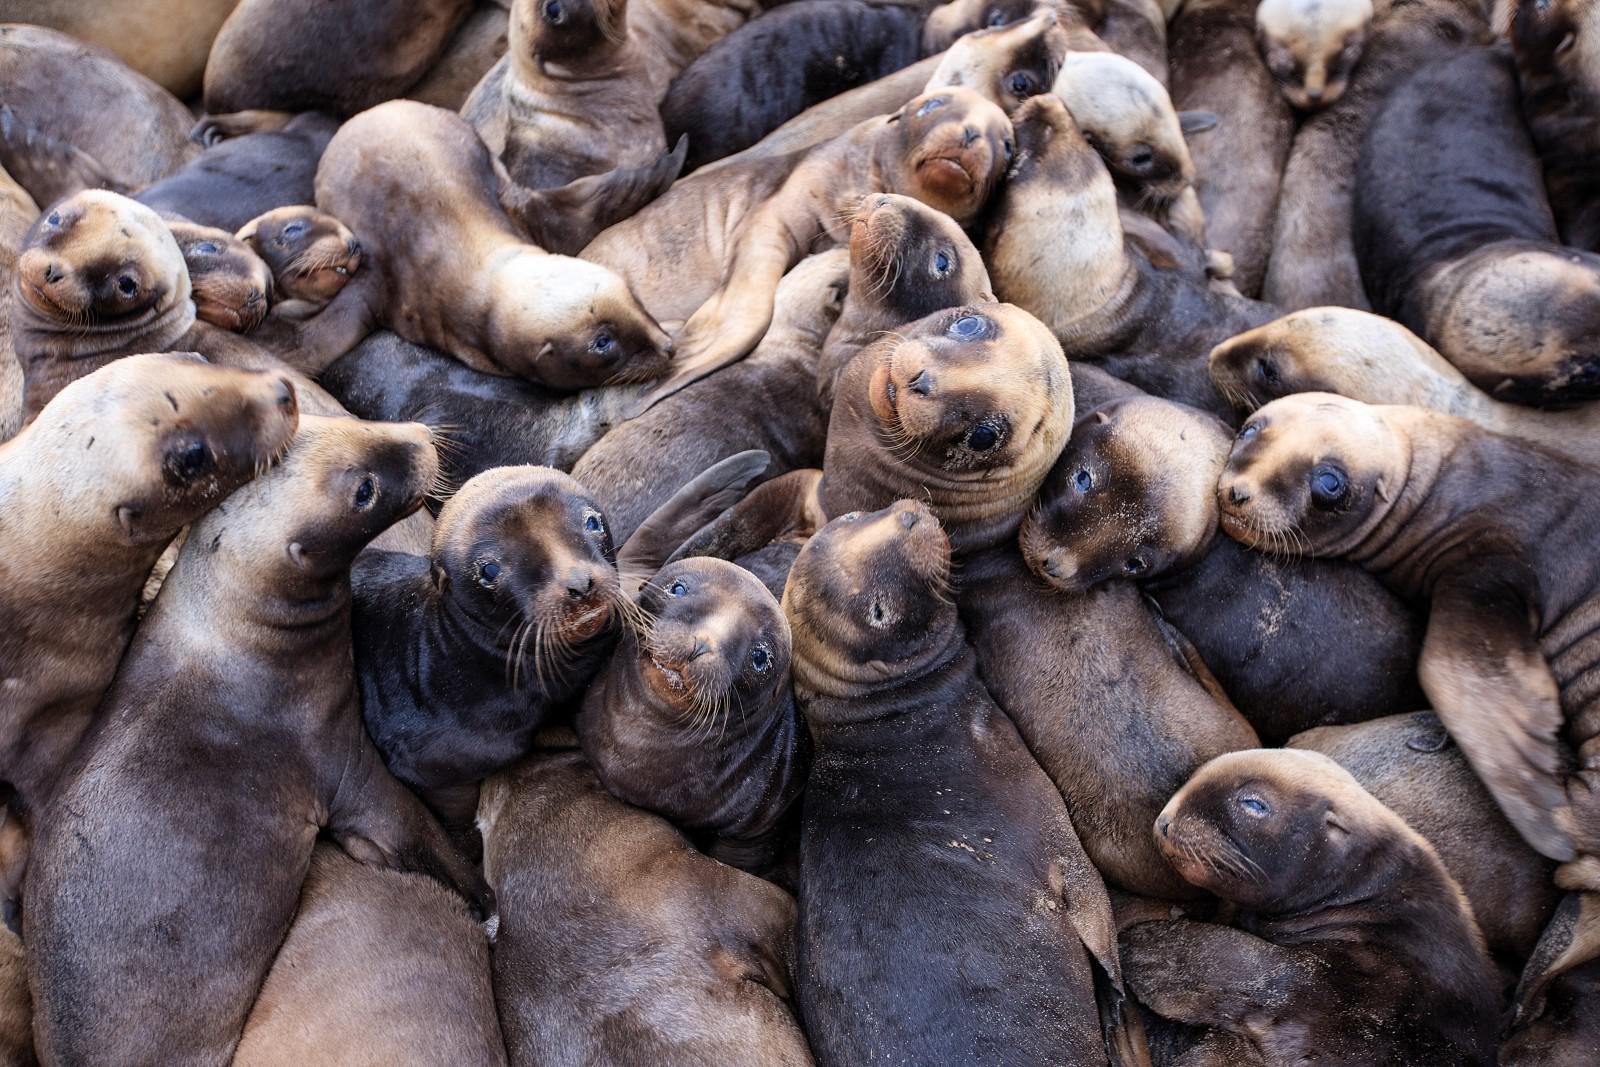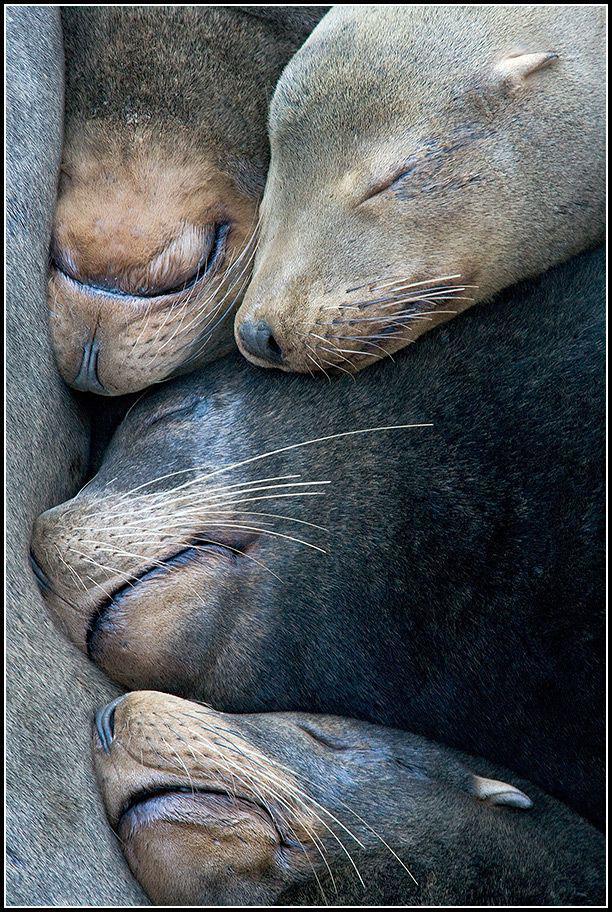The first image is the image on the left, the second image is the image on the right. Considering the images on both sides, is "The right image contains no more than four seals." valid? Answer yes or no. Yes. The first image is the image on the left, the second image is the image on the right. For the images displayed, is the sentence "Exactly four seal heads are visible in one of the images." factually correct? Answer yes or no. Yes. 